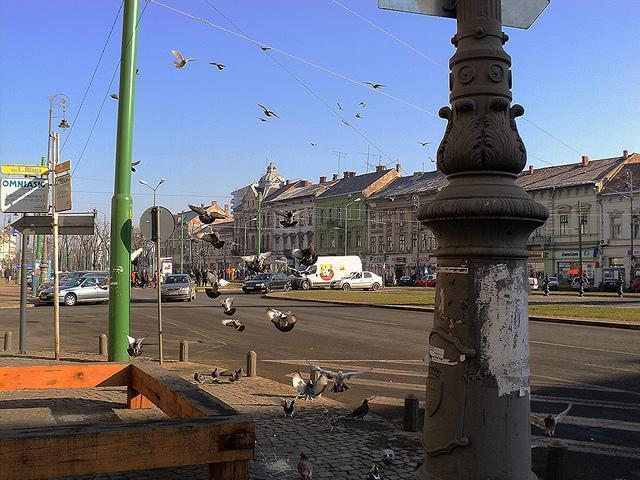Those birds are related to what other type of bird?
Choose the right answer from the provided options to respond to the question.
Options: Raven, robin, peacock, dove. Dove. 